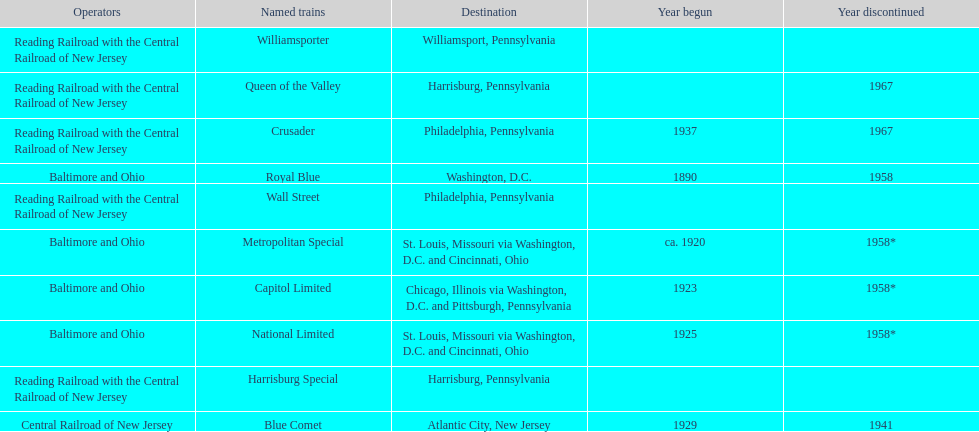How many trains were discontinued in 1958? 4. 